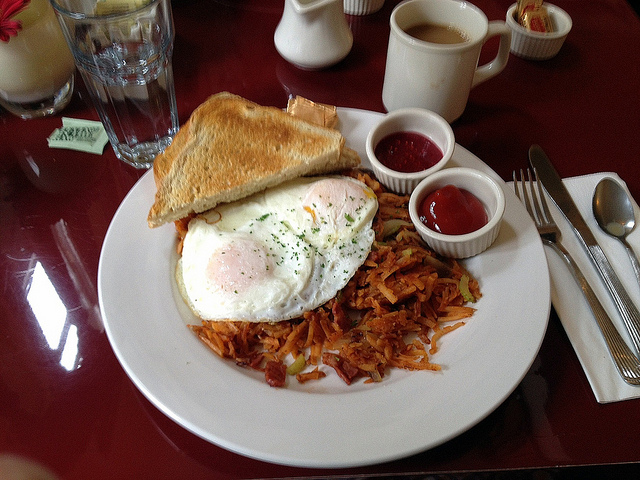Imagine a backstory for the person who made this breakfast. The person who made this breakfast is a passionate food lover named Alex. Alex lives in a cozy apartment in a bustling city and enjoys cooking as a way to relax and start the day on a positive note. On weekends, Alex often visits the local farmer's market to pick up fresh ingredients. This particular breakfast was made with great care early on a sunny Sunday morning, using farm-fresh eggs, homemade whole wheat bread, and organic potatoes. Alex enjoys experimenting with different toppings and condiments, adding local jams and freshly ground pepper to bring out the best flavors. Cooking for friends and loved ones is Alex's way of showing appreciation, and this breakfast was made to share with a dear friend, creating a moment of joy and connection. 